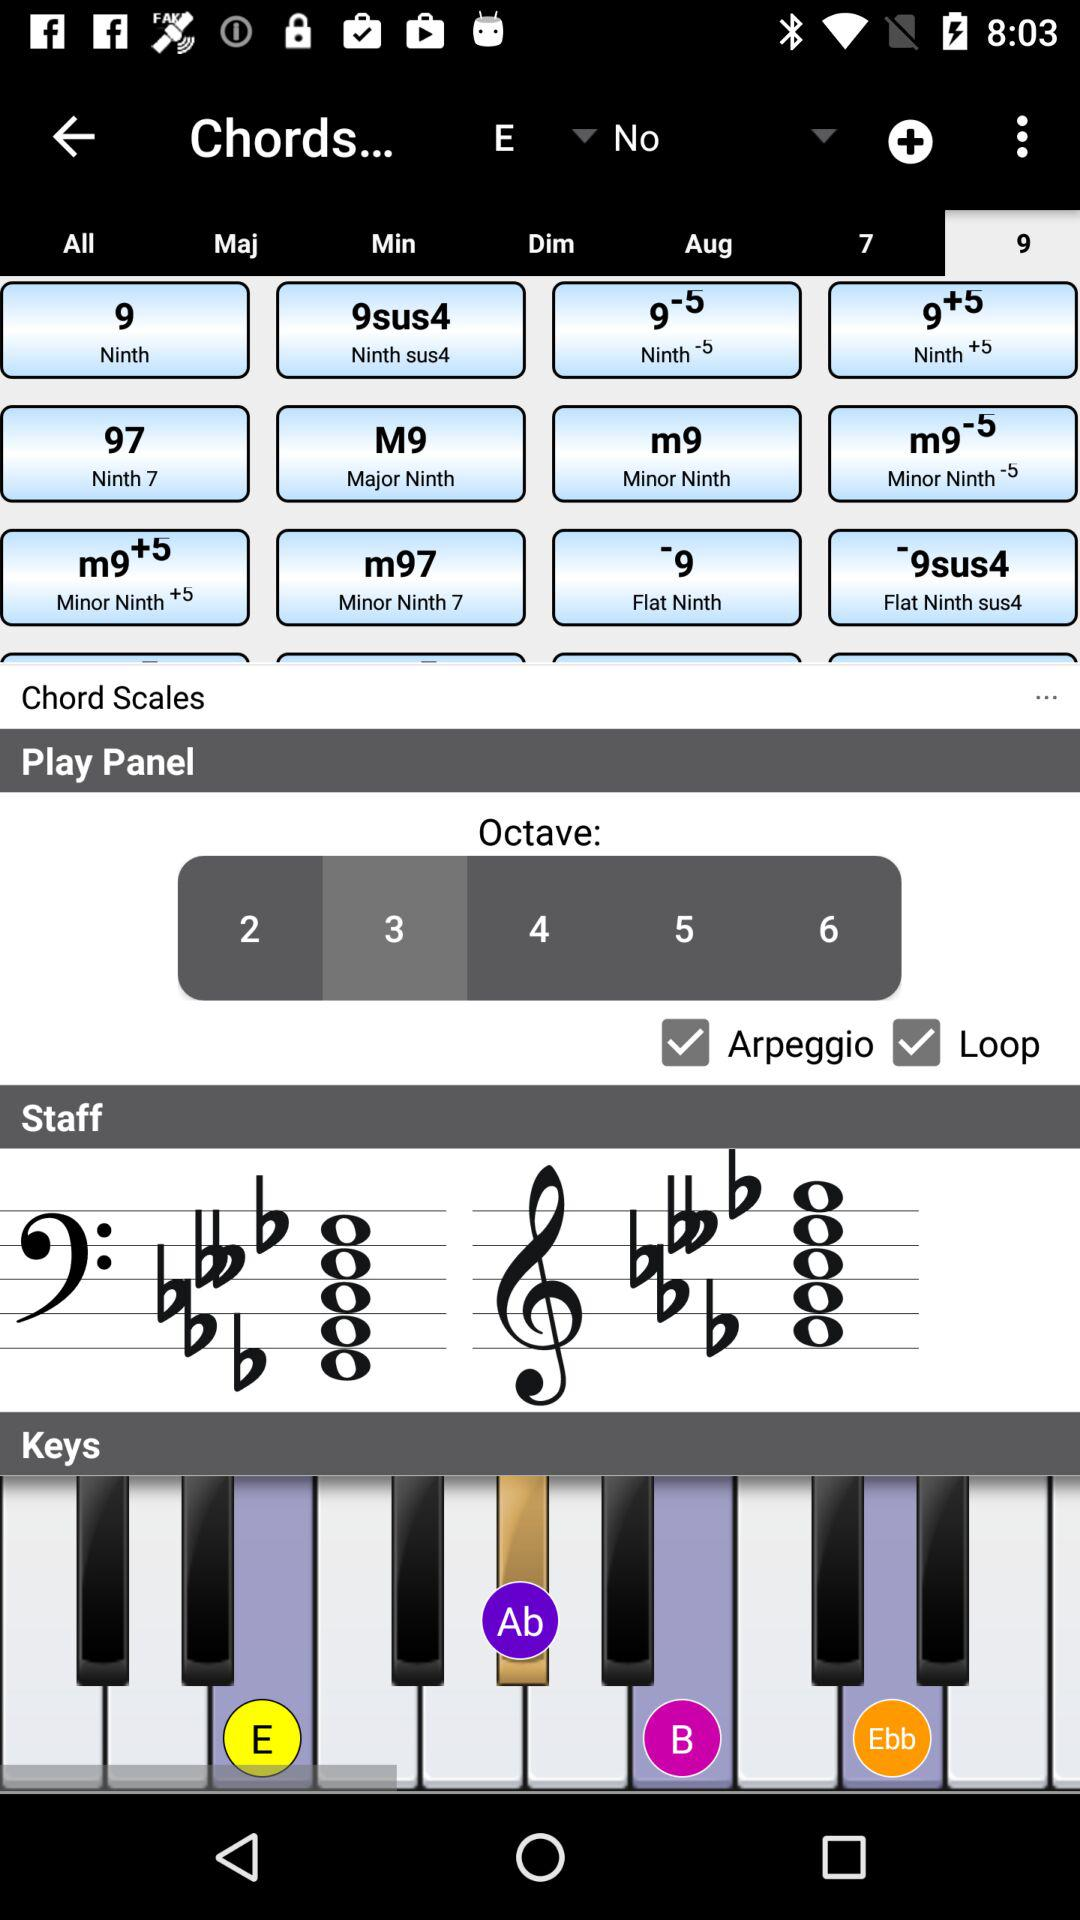Which tab is selected in "Chords"? The selected tab is "9". 